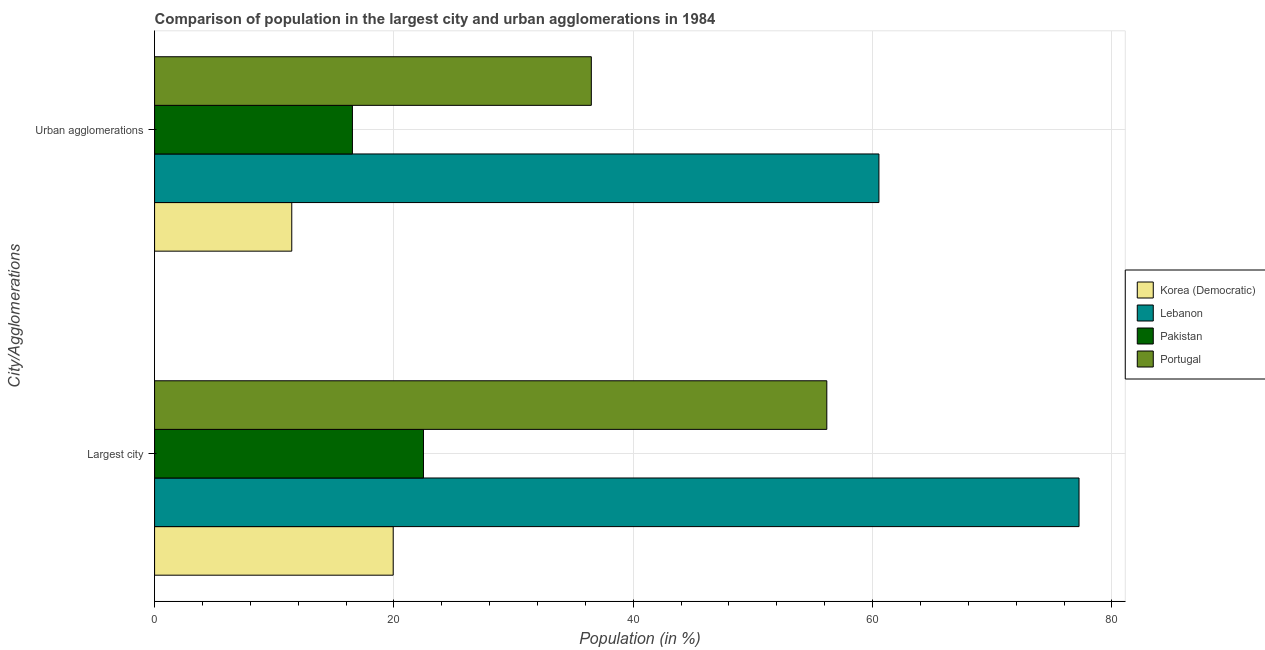Are the number of bars on each tick of the Y-axis equal?
Provide a succinct answer. Yes. How many bars are there on the 2nd tick from the bottom?
Provide a succinct answer. 4. What is the label of the 2nd group of bars from the top?
Your answer should be compact. Largest city. What is the population in the largest city in Portugal?
Provide a succinct answer. 56.18. Across all countries, what is the maximum population in the largest city?
Offer a very short reply. 77.25. Across all countries, what is the minimum population in urban agglomerations?
Offer a terse response. 11.47. In which country was the population in the largest city maximum?
Your response must be concise. Lebanon. In which country was the population in the largest city minimum?
Your answer should be very brief. Korea (Democratic). What is the total population in urban agglomerations in the graph?
Ensure brevity in your answer.  125.03. What is the difference between the population in urban agglomerations in Korea (Democratic) and that in Pakistan?
Offer a terse response. -5.07. What is the difference between the population in the largest city in Korea (Democratic) and the population in urban agglomerations in Portugal?
Offer a very short reply. -16.56. What is the average population in the largest city per country?
Provide a succinct answer. 43.96. What is the difference between the population in the largest city and population in urban agglomerations in Pakistan?
Keep it short and to the point. 5.94. What is the ratio of the population in the largest city in Portugal to that in Pakistan?
Your answer should be compact. 2.5. Is the population in urban agglomerations in Korea (Democratic) less than that in Lebanon?
Your answer should be very brief. Yes. What does the 1st bar from the bottom in Urban agglomerations represents?
Your answer should be compact. Korea (Democratic). How many bars are there?
Make the answer very short. 8. What is the difference between two consecutive major ticks on the X-axis?
Offer a terse response. 20. Are the values on the major ticks of X-axis written in scientific E-notation?
Your response must be concise. No. Does the graph contain any zero values?
Offer a terse response. No. Where does the legend appear in the graph?
Provide a short and direct response. Center right. What is the title of the graph?
Offer a terse response. Comparison of population in the largest city and urban agglomerations in 1984. What is the label or title of the Y-axis?
Make the answer very short. City/Agglomerations. What is the Population (in %) in Korea (Democratic) in Largest city?
Your answer should be very brief. 19.94. What is the Population (in %) of Lebanon in Largest city?
Provide a succinct answer. 77.25. What is the Population (in %) of Pakistan in Largest city?
Keep it short and to the point. 22.47. What is the Population (in %) in Portugal in Largest city?
Keep it short and to the point. 56.18. What is the Population (in %) of Korea (Democratic) in Urban agglomerations?
Provide a short and direct response. 11.47. What is the Population (in %) in Lebanon in Urban agglomerations?
Offer a very short reply. 60.53. What is the Population (in %) of Pakistan in Urban agglomerations?
Offer a terse response. 16.53. What is the Population (in %) of Portugal in Urban agglomerations?
Provide a succinct answer. 36.5. Across all City/Agglomerations, what is the maximum Population (in %) of Korea (Democratic)?
Your response must be concise. 19.94. Across all City/Agglomerations, what is the maximum Population (in %) in Lebanon?
Your response must be concise. 77.25. Across all City/Agglomerations, what is the maximum Population (in %) of Pakistan?
Offer a terse response. 22.47. Across all City/Agglomerations, what is the maximum Population (in %) of Portugal?
Your answer should be compact. 56.18. Across all City/Agglomerations, what is the minimum Population (in %) in Korea (Democratic)?
Make the answer very short. 11.47. Across all City/Agglomerations, what is the minimum Population (in %) in Lebanon?
Provide a succinct answer. 60.53. Across all City/Agglomerations, what is the minimum Population (in %) of Pakistan?
Give a very brief answer. 16.53. Across all City/Agglomerations, what is the minimum Population (in %) of Portugal?
Provide a succinct answer. 36.5. What is the total Population (in %) of Korea (Democratic) in the graph?
Your response must be concise. 31.41. What is the total Population (in %) in Lebanon in the graph?
Ensure brevity in your answer.  137.78. What is the total Population (in %) of Pakistan in the graph?
Provide a short and direct response. 39. What is the total Population (in %) of Portugal in the graph?
Your answer should be compact. 92.67. What is the difference between the Population (in %) of Korea (Democratic) in Largest city and that in Urban agglomerations?
Give a very brief answer. 8.48. What is the difference between the Population (in %) in Lebanon in Largest city and that in Urban agglomerations?
Provide a succinct answer. 16.72. What is the difference between the Population (in %) in Pakistan in Largest city and that in Urban agglomerations?
Keep it short and to the point. 5.94. What is the difference between the Population (in %) in Portugal in Largest city and that in Urban agglomerations?
Give a very brief answer. 19.68. What is the difference between the Population (in %) of Korea (Democratic) in Largest city and the Population (in %) of Lebanon in Urban agglomerations?
Keep it short and to the point. -40.59. What is the difference between the Population (in %) in Korea (Democratic) in Largest city and the Population (in %) in Pakistan in Urban agglomerations?
Your answer should be very brief. 3.41. What is the difference between the Population (in %) of Korea (Democratic) in Largest city and the Population (in %) of Portugal in Urban agglomerations?
Provide a short and direct response. -16.56. What is the difference between the Population (in %) of Lebanon in Largest city and the Population (in %) of Pakistan in Urban agglomerations?
Make the answer very short. 60.72. What is the difference between the Population (in %) of Lebanon in Largest city and the Population (in %) of Portugal in Urban agglomerations?
Keep it short and to the point. 40.76. What is the difference between the Population (in %) in Pakistan in Largest city and the Population (in %) in Portugal in Urban agglomerations?
Give a very brief answer. -14.03. What is the average Population (in %) of Korea (Democratic) per City/Agglomerations?
Provide a short and direct response. 15.7. What is the average Population (in %) of Lebanon per City/Agglomerations?
Offer a terse response. 68.89. What is the average Population (in %) in Pakistan per City/Agglomerations?
Your answer should be very brief. 19.5. What is the average Population (in %) in Portugal per City/Agglomerations?
Provide a succinct answer. 46.34. What is the difference between the Population (in %) in Korea (Democratic) and Population (in %) in Lebanon in Largest city?
Your response must be concise. -57.31. What is the difference between the Population (in %) of Korea (Democratic) and Population (in %) of Pakistan in Largest city?
Provide a short and direct response. -2.53. What is the difference between the Population (in %) in Korea (Democratic) and Population (in %) in Portugal in Largest city?
Keep it short and to the point. -36.24. What is the difference between the Population (in %) of Lebanon and Population (in %) of Pakistan in Largest city?
Give a very brief answer. 54.78. What is the difference between the Population (in %) in Lebanon and Population (in %) in Portugal in Largest city?
Provide a short and direct response. 21.08. What is the difference between the Population (in %) in Pakistan and Population (in %) in Portugal in Largest city?
Give a very brief answer. -33.71. What is the difference between the Population (in %) in Korea (Democratic) and Population (in %) in Lebanon in Urban agglomerations?
Your answer should be compact. -49.06. What is the difference between the Population (in %) in Korea (Democratic) and Population (in %) in Pakistan in Urban agglomerations?
Your answer should be compact. -5.07. What is the difference between the Population (in %) in Korea (Democratic) and Population (in %) in Portugal in Urban agglomerations?
Your answer should be very brief. -25.03. What is the difference between the Population (in %) of Lebanon and Population (in %) of Pakistan in Urban agglomerations?
Your response must be concise. 44. What is the difference between the Population (in %) of Lebanon and Population (in %) of Portugal in Urban agglomerations?
Ensure brevity in your answer.  24.03. What is the difference between the Population (in %) of Pakistan and Population (in %) of Portugal in Urban agglomerations?
Offer a very short reply. -19.96. What is the ratio of the Population (in %) of Korea (Democratic) in Largest city to that in Urban agglomerations?
Offer a terse response. 1.74. What is the ratio of the Population (in %) of Lebanon in Largest city to that in Urban agglomerations?
Provide a short and direct response. 1.28. What is the ratio of the Population (in %) of Pakistan in Largest city to that in Urban agglomerations?
Your answer should be very brief. 1.36. What is the ratio of the Population (in %) in Portugal in Largest city to that in Urban agglomerations?
Make the answer very short. 1.54. What is the difference between the highest and the second highest Population (in %) in Korea (Democratic)?
Provide a succinct answer. 8.48. What is the difference between the highest and the second highest Population (in %) of Lebanon?
Keep it short and to the point. 16.72. What is the difference between the highest and the second highest Population (in %) of Pakistan?
Ensure brevity in your answer.  5.94. What is the difference between the highest and the second highest Population (in %) in Portugal?
Provide a short and direct response. 19.68. What is the difference between the highest and the lowest Population (in %) in Korea (Democratic)?
Give a very brief answer. 8.48. What is the difference between the highest and the lowest Population (in %) in Lebanon?
Keep it short and to the point. 16.72. What is the difference between the highest and the lowest Population (in %) of Pakistan?
Provide a succinct answer. 5.94. What is the difference between the highest and the lowest Population (in %) of Portugal?
Your answer should be very brief. 19.68. 